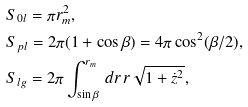Convert formula to latex. <formula><loc_0><loc_0><loc_500><loc_500>& S _ { 0 l } = \pi r _ { m } ^ { 2 } , \\ & S _ { p l } = 2 \pi ( 1 + \cos \beta ) = 4 \pi \cos ^ { 2 } ( \beta / 2 ) , \\ & S _ { l g } = 2 \pi \int _ { \sin \beta } ^ { r _ { m } } \, d r \, r \sqrt { 1 + \dot { z } ^ { 2 } } ,</formula> 